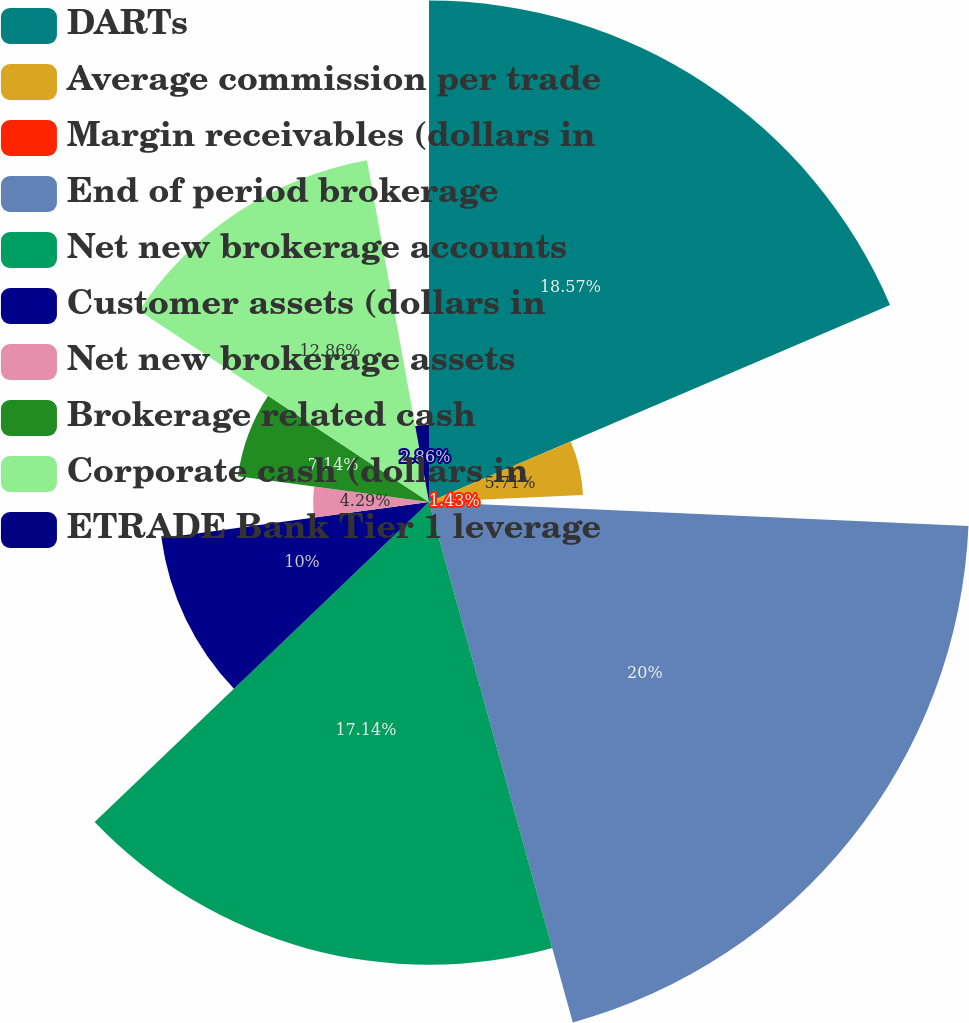Convert chart to OTSL. <chart><loc_0><loc_0><loc_500><loc_500><pie_chart><fcel>DARTs<fcel>Average commission per trade<fcel>Margin receivables (dollars in<fcel>End of period brokerage<fcel>Net new brokerage accounts<fcel>Customer assets (dollars in<fcel>Net new brokerage assets<fcel>Brokerage related cash<fcel>Corporate cash (dollars in<fcel>ETRADE Bank Tier 1 leverage<nl><fcel>18.57%<fcel>5.71%<fcel>1.43%<fcel>20.0%<fcel>17.14%<fcel>10.0%<fcel>4.29%<fcel>7.14%<fcel>12.86%<fcel>2.86%<nl></chart> 